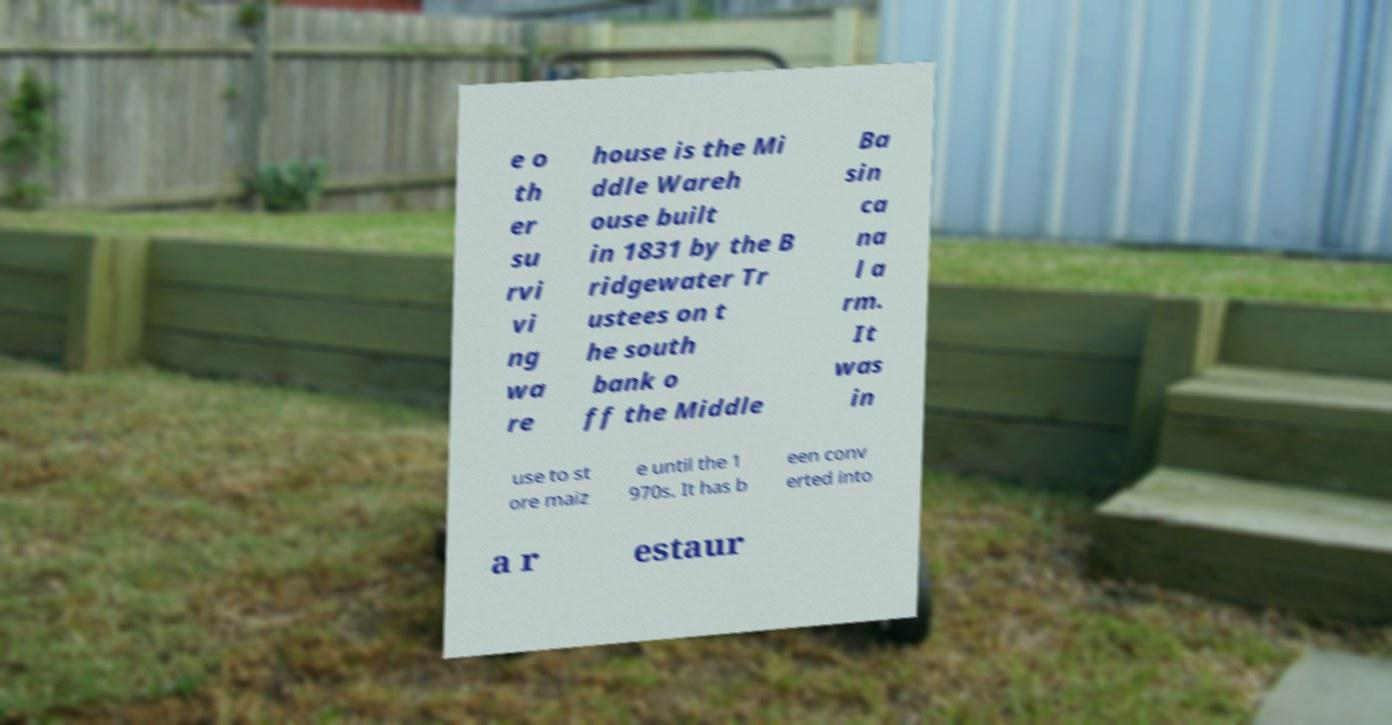Please read and relay the text visible in this image. What does it say? e o th er su rvi vi ng wa re house is the Mi ddle Wareh ouse built in 1831 by the B ridgewater Tr ustees on t he south bank o ff the Middle Ba sin ca na l a rm. It was in use to st ore maiz e until the 1 970s. It has b een conv erted into a r estaur 